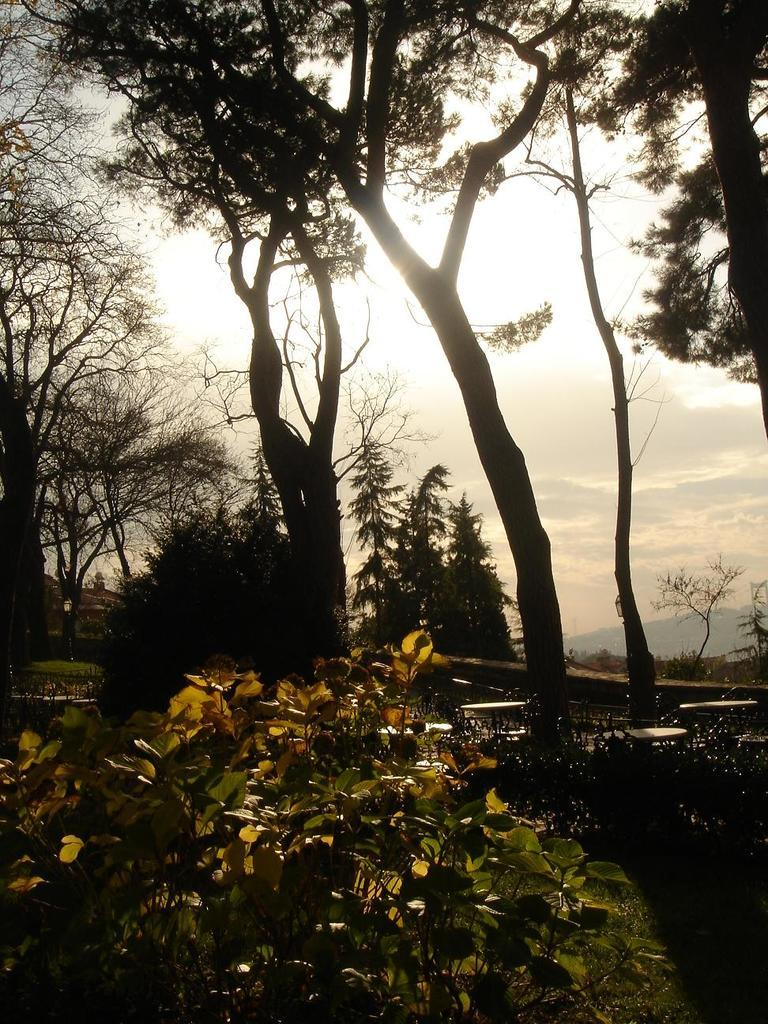What type of vegetation can be seen on the ground in the image? There are plants and trees on the ground in the image. What is visible at the top of the image? The sky is visible at the top of the image. What type of landscape feature can be seen in the background of the image? There are mountains in the background of the image. What type of underwear is hanging on the tree in the image? There is no underwear present in the image; it features plants, trees, the sky, and mountains. Can you provide an example of a plant that can be seen in the image? The image does not require an example of a plant, as it is clear from the provided facts that there are plants and trees visible on the ground. 